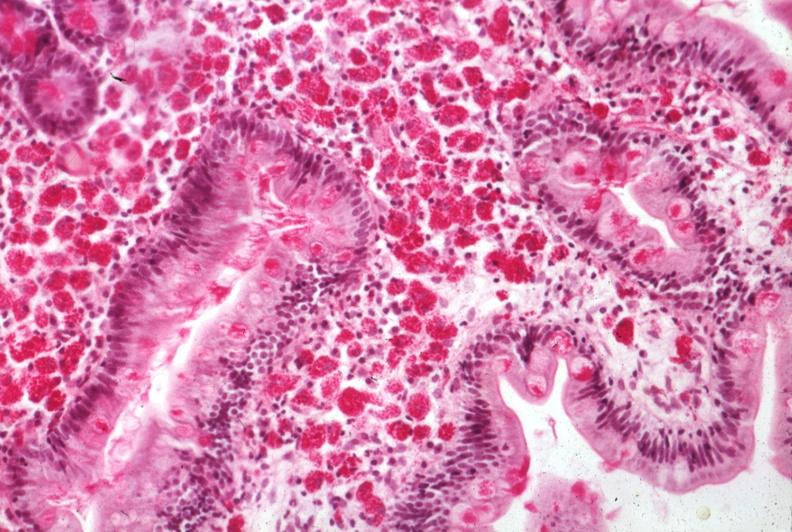s pus in test tube present?
Answer the question using a single word or phrase. No 